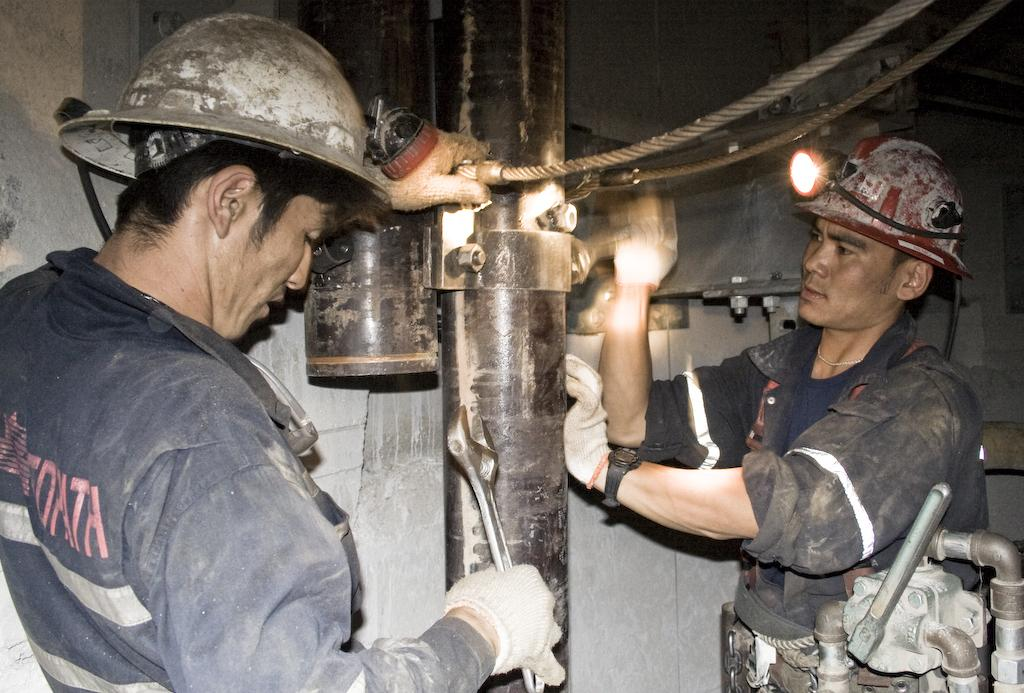How many people are in the image? There are two persons in the image. What are the persons wearing? The persons are wearing hi vis jackets and helmets. What are the persons holding in their hands? The persons are holding tools in their hands. What are the persons doing in the image? The two persons are working on a metal rod. What type of discovery did the brothers make in the image? There is no mention of brothers or any discovery in the image; it features two persons working on a metal rod. 